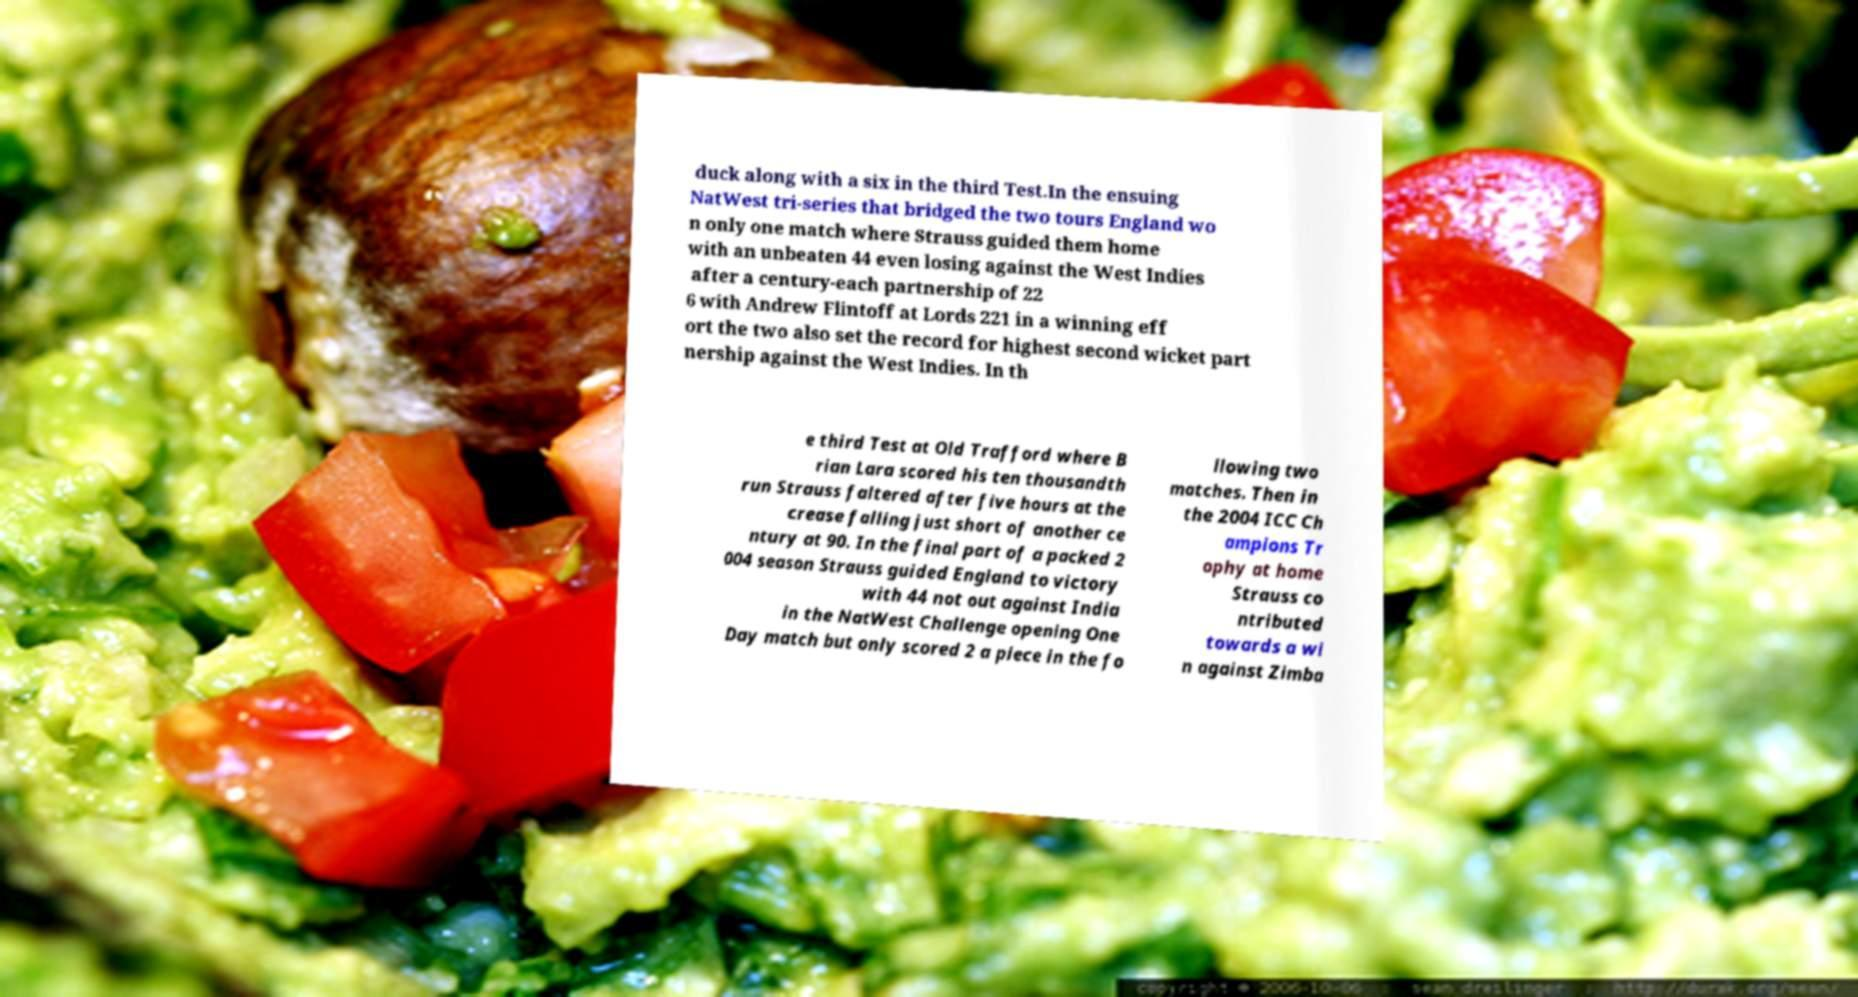Can you accurately transcribe the text from the provided image for me? duck along with a six in the third Test.In the ensuing NatWest tri-series that bridged the two tours England wo n only one match where Strauss guided them home with an unbeaten 44 even losing against the West Indies after a century-each partnership of 22 6 with Andrew Flintoff at Lords 221 in a winning eff ort the two also set the record for highest second wicket part nership against the West Indies. In th e third Test at Old Trafford where B rian Lara scored his ten thousandth run Strauss faltered after five hours at the crease falling just short of another ce ntury at 90. In the final part of a packed 2 004 season Strauss guided England to victory with 44 not out against India in the NatWest Challenge opening One Day match but only scored 2 a piece in the fo llowing two matches. Then in the 2004 ICC Ch ampions Tr ophy at home Strauss co ntributed towards a wi n against Zimba 